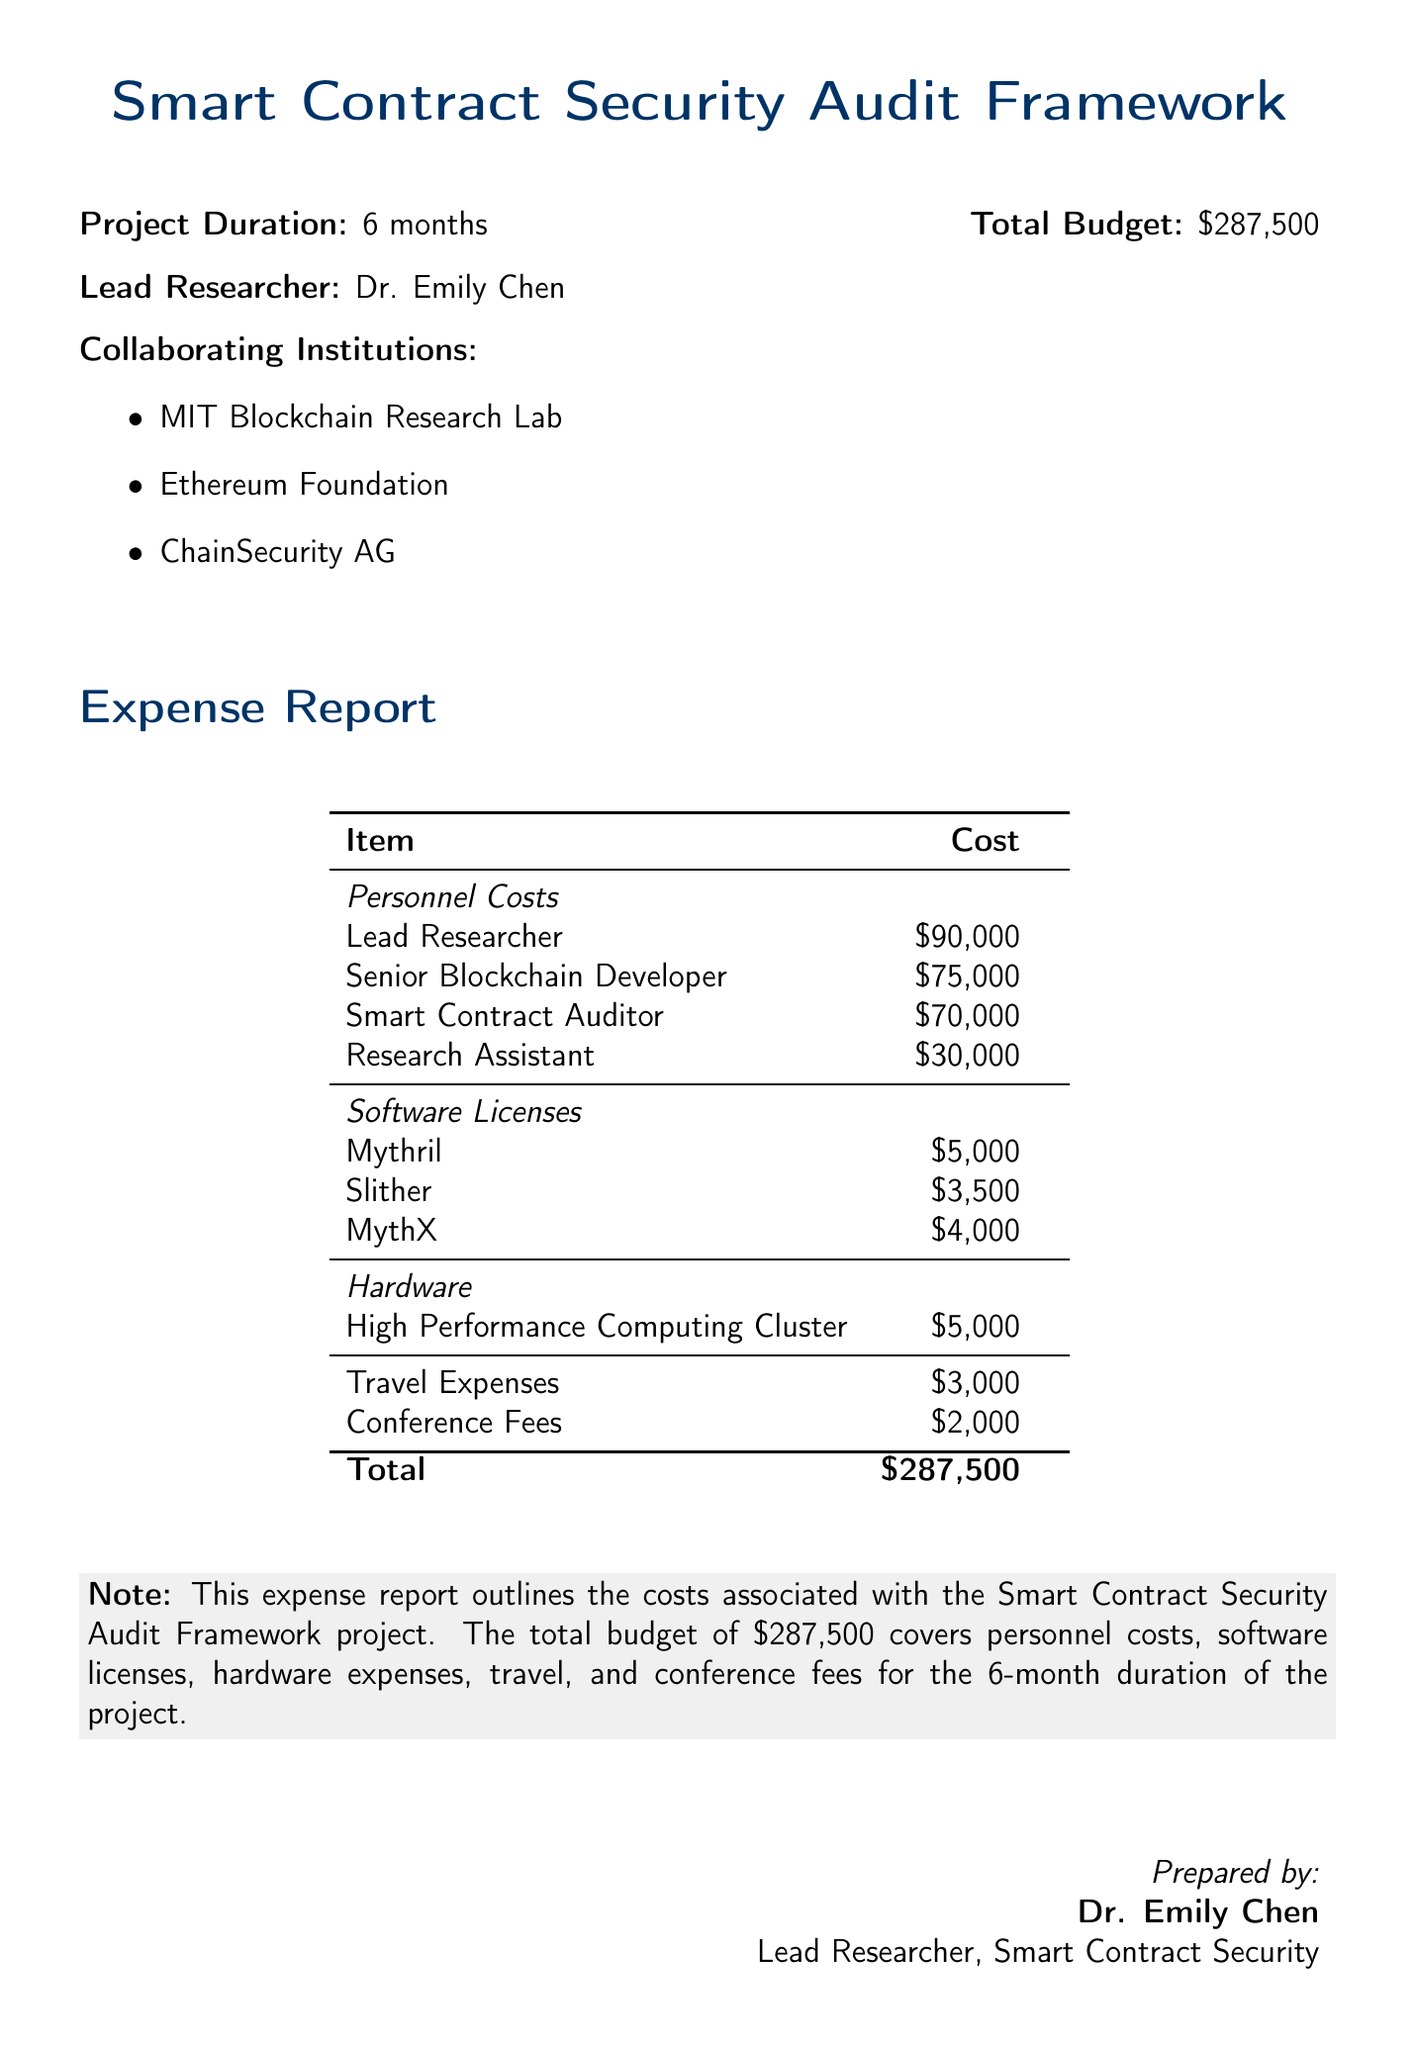What is the project duration? The project duration is specified in the document as a duration of 6 months.
Answer: 6 months Who is the lead researcher? The lead researcher is mentioned in the document as Dr. Emily Chen.
Answer: Dr. Emily Chen What is the total budget for the project? The document states the total budget for the project as $287,500.
Answer: $287,500 How much is allocated for travel expenses? The travel expenses are listed in the expense report, which shows $3,000 allocated for this category.
Answer: $3,000 What is the cost of the Smart Contract Auditor? The expense report specifies that the cost of the Smart Contract Auditor is $70,000.
Answer: $70,000 How many collaborating institutions are mentioned? The document lists three collaborating institutions involved in the project.
Answer: 3 What is the total amount spent on software licenses? The costs of software licenses are totaled by adding them together, resulting in $12,500.
Answer: $12,500 What type of document is this? This is a detailed expense report for a research project.
Answer: Expense report What is the cost of the High Performance Computing Cluster? The document shows that the cost of the High Performance Computing Cluster is $5,000.
Answer: $5,000 How much is the Lead Researcher’s salary? The salary of the Lead Researcher is specified as $90,000 in the document.
Answer: $90,000 